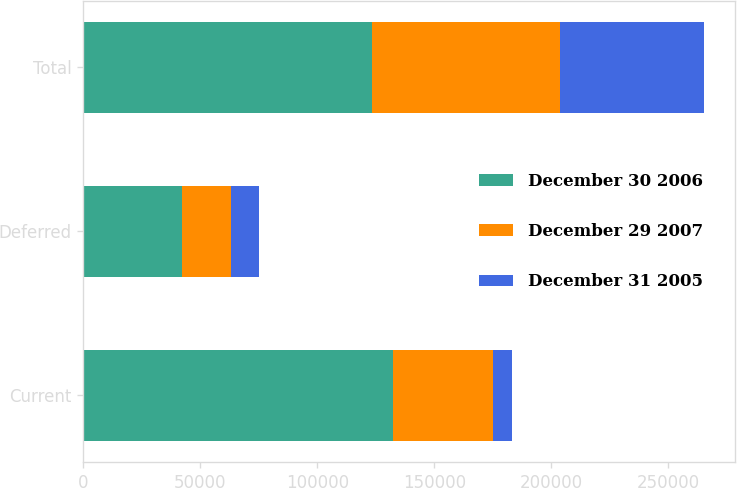Convert chart to OTSL. <chart><loc_0><loc_0><loc_500><loc_500><stacked_bar_chart><ecel><fcel>Current<fcel>Deferred<fcel>Total<nl><fcel>December 30 2006<fcel>132452<fcel>42193<fcel>123262<nl><fcel>December 29 2007<fcel>42850<fcel>21153<fcel>80431<nl><fcel>December 31 2005<fcel>7738<fcel>11741<fcel>61381<nl></chart> 